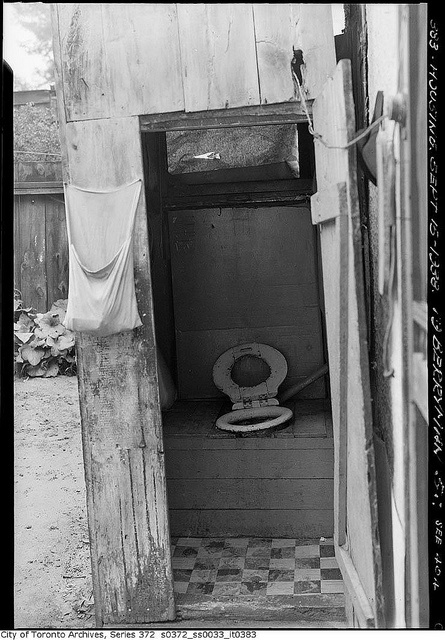Describe the objects in this image and their specific colors. I can see a toilet in black and gray tones in this image. 